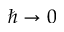Convert formula to latex. <formula><loc_0><loc_0><loc_500><loc_500>\hbar { \rightarrow } 0</formula> 